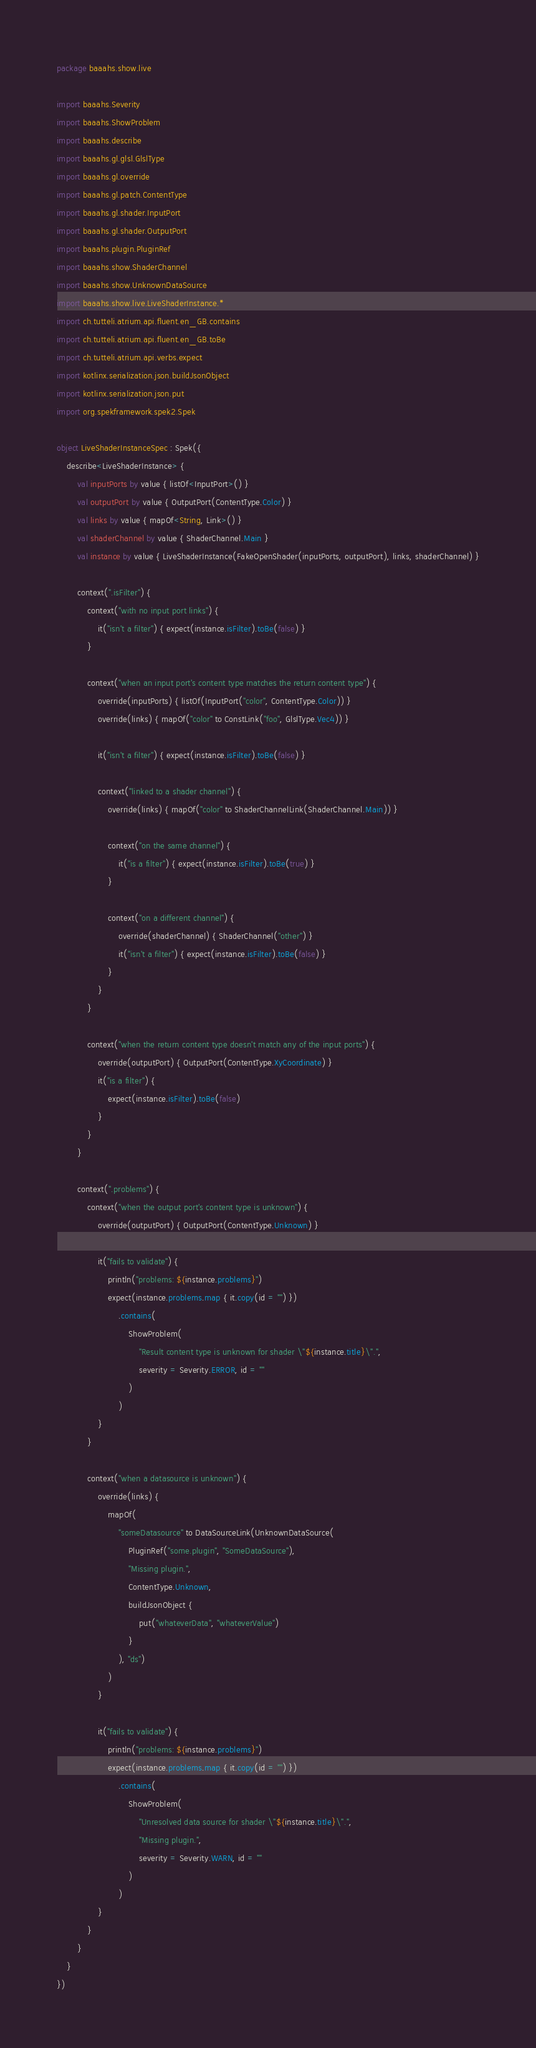<code> <loc_0><loc_0><loc_500><loc_500><_Kotlin_>package baaahs.show.live

import baaahs.Severity
import baaahs.ShowProblem
import baaahs.describe
import baaahs.gl.glsl.GlslType
import baaahs.gl.override
import baaahs.gl.patch.ContentType
import baaahs.gl.shader.InputPort
import baaahs.gl.shader.OutputPort
import baaahs.plugin.PluginRef
import baaahs.show.ShaderChannel
import baaahs.show.UnknownDataSource
import baaahs.show.live.LiveShaderInstance.*
import ch.tutteli.atrium.api.fluent.en_GB.contains
import ch.tutteli.atrium.api.fluent.en_GB.toBe
import ch.tutteli.atrium.api.verbs.expect
import kotlinx.serialization.json.buildJsonObject
import kotlinx.serialization.json.put
import org.spekframework.spek2.Spek

object LiveShaderInstanceSpec : Spek({
    describe<LiveShaderInstance> {
        val inputPorts by value { listOf<InputPort>() }
        val outputPort by value { OutputPort(ContentType.Color) }
        val links by value { mapOf<String, Link>() }
        val shaderChannel by value { ShaderChannel.Main }
        val instance by value { LiveShaderInstance(FakeOpenShader(inputPorts, outputPort), links, shaderChannel) }

        context(".isFilter") {
            context("with no input port links") {
                it("isn't a filter") { expect(instance.isFilter).toBe(false) }
            }

            context("when an input port's content type matches the return content type") {
                override(inputPorts) { listOf(InputPort("color", ContentType.Color)) }
                override(links) { mapOf("color" to ConstLink("foo", GlslType.Vec4)) }

                it("isn't a filter") { expect(instance.isFilter).toBe(false) }

                context("linked to a shader channel") {
                    override(links) { mapOf("color" to ShaderChannelLink(ShaderChannel.Main)) }

                    context("on the same channel") {
                        it("is a filter") { expect(instance.isFilter).toBe(true) }
                    }

                    context("on a different channel") {
                        override(shaderChannel) { ShaderChannel("other") }
                        it("isn't a filter") { expect(instance.isFilter).toBe(false) }
                    }
                }
            }

            context("when the return content type doesn't match any of the input ports") {
                override(outputPort) { OutputPort(ContentType.XyCoordinate) }
                it("is a filter") {
                    expect(instance.isFilter).toBe(false)
                }
            }
        }

        context(".problems") {
            context("when the output port's content type is unknown") {
                override(outputPort) { OutputPort(ContentType.Unknown) }

                it("fails to validate") {
                    println("problems: ${instance.problems}")
                    expect(instance.problems.map { it.copy(id = "") })
                        .contains(
                            ShowProblem(
                                "Result content type is unknown for shader \"${instance.title}\".",
                                severity = Severity.ERROR, id = ""
                            )
                        )
                }
            }

            context("when a datasource is unknown") {
                override(links) {
                    mapOf(
                        "someDatasource" to DataSourceLink(UnknownDataSource(
                            PluginRef("some.plugin", "SomeDataSource"),
                            "Missing plugin.",
                            ContentType.Unknown,
                            buildJsonObject {
                                put("whateverData", "whateverValue")
                            }
                        ), "ds")
                    )
                }

                it("fails to validate") {
                    println("problems: ${instance.problems}")
                    expect(instance.problems.map { it.copy(id = "") })
                        .contains(
                            ShowProblem(
                                "Unresolved data source for shader \"${instance.title}\".",
                                "Missing plugin.",
                                severity = Severity.WARN, id = ""
                            )
                        )
                }
            }
        }
    }
})</code> 